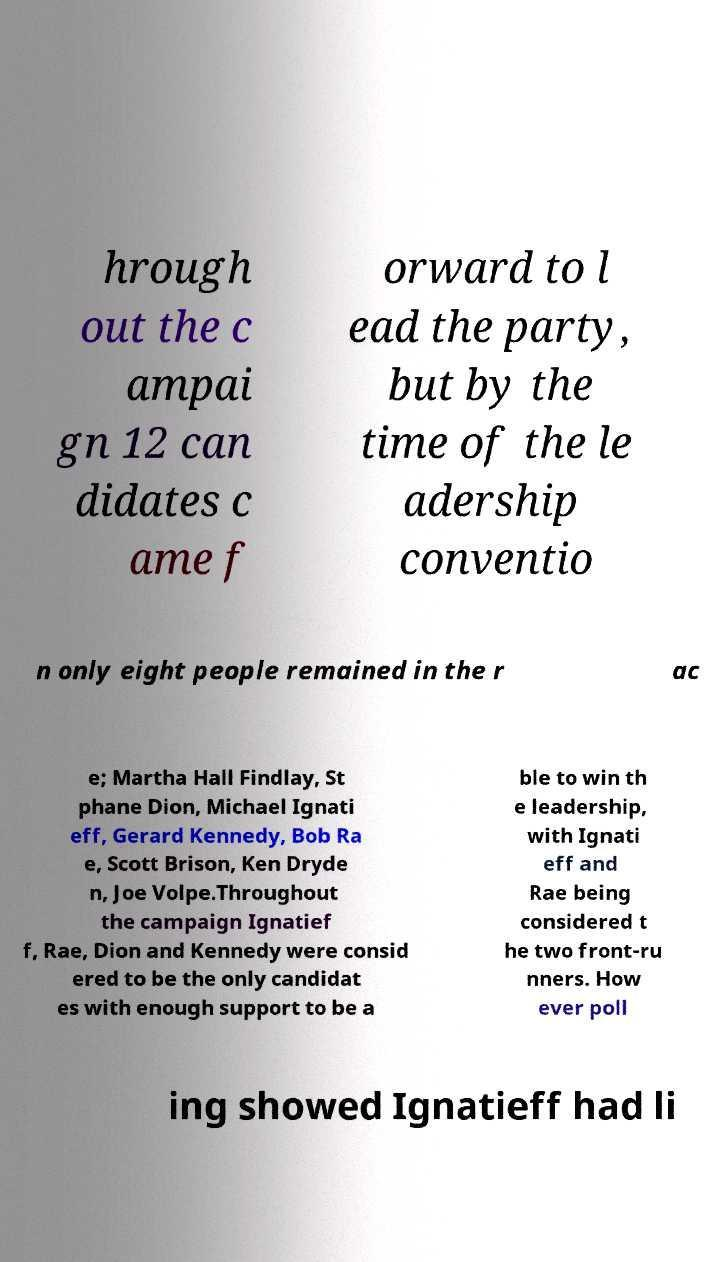For documentation purposes, I need the text within this image transcribed. Could you provide that? hrough out the c ampai gn 12 can didates c ame f orward to l ead the party, but by the time of the le adership conventio n only eight people remained in the r ac e; Martha Hall Findlay, St phane Dion, Michael Ignati eff, Gerard Kennedy, Bob Ra e, Scott Brison, Ken Dryde n, Joe Volpe.Throughout the campaign Ignatief f, Rae, Dion and Kennedy were consid ered to be the only candidat es with enough support to be a ble to win th e leadership, with Ignati eff and Rae being considered t he two front-ru nners. How ever poll ing showed Ignatieff had li 